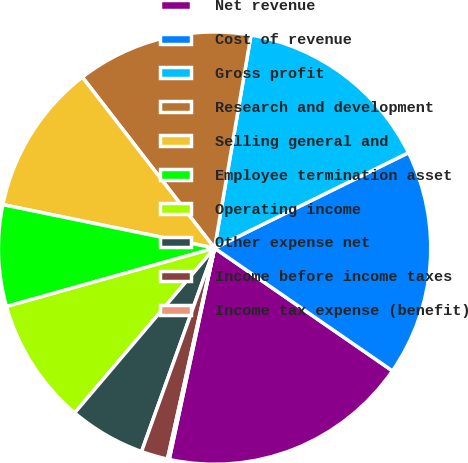<chart> <loc_0><loc_0><loc_500><loc_500><pie_chart><fcel>Net revenue<fcel>Cost of revenue<fcel>Gross profit<fcel>Research and development<fcel>Selling general and<fcel>Employee termination asset<fcel>Operating income<fcel>Other expense net<fcel>Income before income taxes<fcel>Income tax expense (benefit)<nl><fcel>18.75%<fcel>16.89%<fcel>15.03%<fcel>13.17%<fcel>11.3%<fcel>7.58%<fcel>9.44%<fcel>5.72%<fcel>1.99%<fcel>0.13%<nl></chart> 